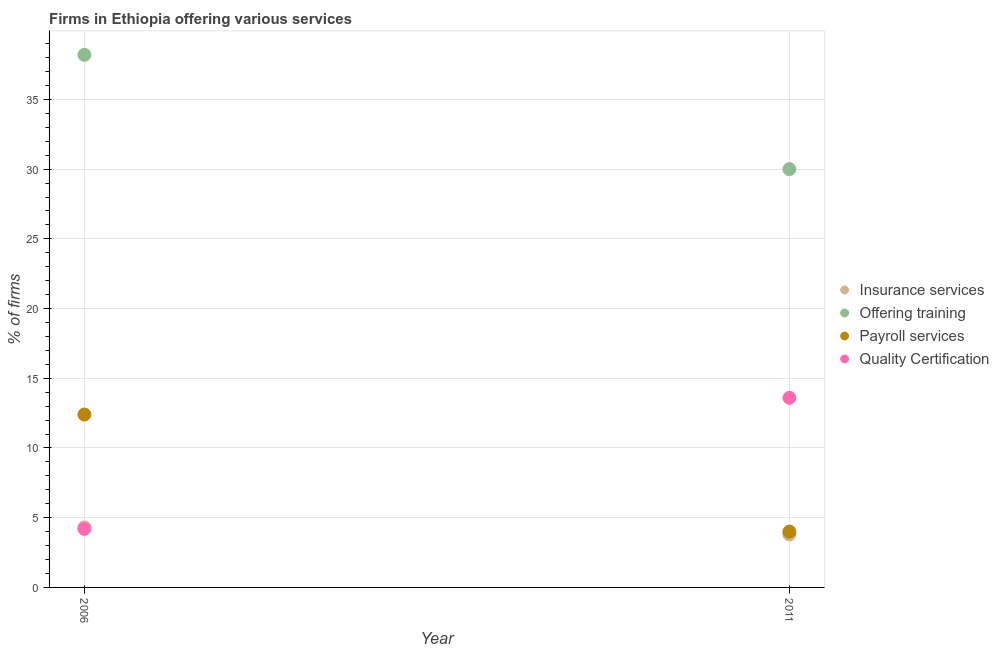What is the percentage of firms offering payroll services in 2011?
Make the answer very short. 4. Across all years, what is the maximum percentage of firms offering payroll services?
Keep it short and to the point. 12.4. In which year was the percentage of firms offering quality certification maximum?
Your answer should be compact. 2011. What is the total percentage of firms offering quality certification in the graph?
Provide a short and direct response. 17.8. What is the difference between the percentage of firms offering quality certification in 2006 and that in 2011?
Your answer should be very brief. -9.4. What is the difference between the percentage of firms offering training in 2011 and the percentage of firms offering insurance services in 2006?
Provide a short and direct response. 25.7. What is the average percentage of firms offering insurance services per year?
Give a very brief answer. 4.05. In the year 2006, what is the difference between the percentage of firms offering insurance services and percentage of firms offering quality certification?
Provide a succinct answer. 0.1. In how many years, is the percentage of firms offering quality certification greater than 23 %?
Your answer should be very brief. 0. What is the ratio of the percentage of firms offering insurance services in 2006 to that in 2011?
Provide a short and direct response. 1.13. Is it the case that in every year, the sum of the percentage of firms offering insurance services and percentage of firms offering training is greater than the percentage of firms offering payroll services?
Provide a succinct answer. Yes. Does the percentage of firms offering insurance services monotonically increase over the years?
Your response must be concise. No. How many years are there in the graph?
Offer a terse response. 2. Are the values on the major ticks of Y-axis written in scientific E-notation?
Keep it short and to the point. No. Does the graph contain grids?
Provide a short and direct response. Yes. Where does the legend appear in the graph?
Make the answer very short. Center right. What is the title of the graph?
Offer a terse response. Firms in Ethiopia offering various services . What is the label or title of the X-axis?
Provide a succinct answer. Year. What is the label or title of the Y-axis?
Make the answer very short. % of firms. What is the % of firms of Insurance services in 2006?
Offer a very short reply. 4.3. What is the % of firms in Offering training in 2006?
Offer a very short reply. 38.2. What is the % of firms in Quality Certification in 2006?
Your answer should be compact. 4.2. What is the % of firms in Offering training in 2011?
Ensure brevity in your answer.  30. What is the % of firms of Payroll services in 2011?
Your answer should be very brief. 4. Across all years, what is the maximum % of firms in Insurance services?
Offer a terse response. 4.3. Across all years, what is the maximum % of firms in Offering training?
Provide a succinct answer. 38.2. Across all years, what is the maximum % of firms in Payroll services?
Provide a succinct answer. 12.4. Across all years, what is the maximum % of firms in Quality Certification?
Ensure brevity in your answer.  13.6. Across all years, what is the minimum % of firms of Insurance services?
Make the answer very short. 3.8. Across all years, what is the minimum % of firms in Quality Certification?
Give a very brief answer. 4.2. What is the total % of firms of Insurance services in the graph?
Your answer should be compact. 8.1. What is the total % of firms of Offering training in the graph?
Your answer should be very brief. 68.2. What is the difference between the % of firms in Quality Certification in 2006 and that in 2011?
Offer a very short reply. -9.4. What is the difference between the % of firms of Insurance services in 2006 and the % of firms of Offering training in 2011?
Your response must be concise. -25.7. What is the difference between the % of firms in Insurance services in 2006 and the % of firms in Payroll services in 2011?
Provide a short and direct response. 0.3. What is the difference between the % of firms of Offering training in 2006 and the % of firms of Payroll services in 2011?
Offer a terse response. 34.2. What is the difference between the % of firms of Offering training in 2006 and the % of firms of Quality Certification in 2011?
Offer a very short reply. 24.6. What is the average % of firms of Insurance services per year?
Offer a very short reply. 4.05. What is the average % of firms in Offering training per year?
Offer a very short reply. 34.1. What is the average % of firms in Quality Certification per year?
Offer a very short reply. 8.9. In the year 2006, what is the difference between the % of firms in Insurance services and % of firms in Offering training?
Offer a terse response. -33.9. In the year 2006, what is the difference between the % of firms in Insurance services and % of firms in Payroll services?
Offer a terse response. -8.1. In the year 2006, what is the difference between the % of firms of Insurance services and % of firms of Quality Certification?
Provide a succinct answer. 0.1. In the year 2006, what is the difference between the % of firms in Offering training and % of firms in Payroll services?
Offer a very short reply. 25.8. In the year 2006, what is the difference between the % of firms in Offering training and % of firms in Quality Certification?
Offer a very short reply. 34. In the year 2011, what is the difference between the % of firms in Insurance services and % of firms in Offering training?
Your answer should be very brief. -26.2. In the year 2011, what is the difference between the % of firms in Insurance services and % of firms in Quality Certification?
Your answer should be very brief. -9.8. In the year 2011, what is the difference between the % of firms in Offering training and % of firms in Quality Certification?
Provide a succinct answer. 16.4. What is the ratio of the % of firms in Insurance services in 2006 to that in 2011?
Your response must be concise. 1.13. What is the ratio of the % of firms of Offering training in 2006 to that in 2011?
Offer a terse response. 1.27. What is the ratio of the % of firms in Quality Certification in 2006 to that in 2011?
Your answer should be very brief. 0.31. What is the difference between the highest and the second highest % of firms in Quality Certification?
Make the answer very short. 9.4. What is the difference between the highest and the lowest % of firms of Insurance services?
Provide a succinct answer. 0.5. What is the difference between the highest and the lowest % of firms of Payroll services?
Provide a succinct answer. 8.4. 